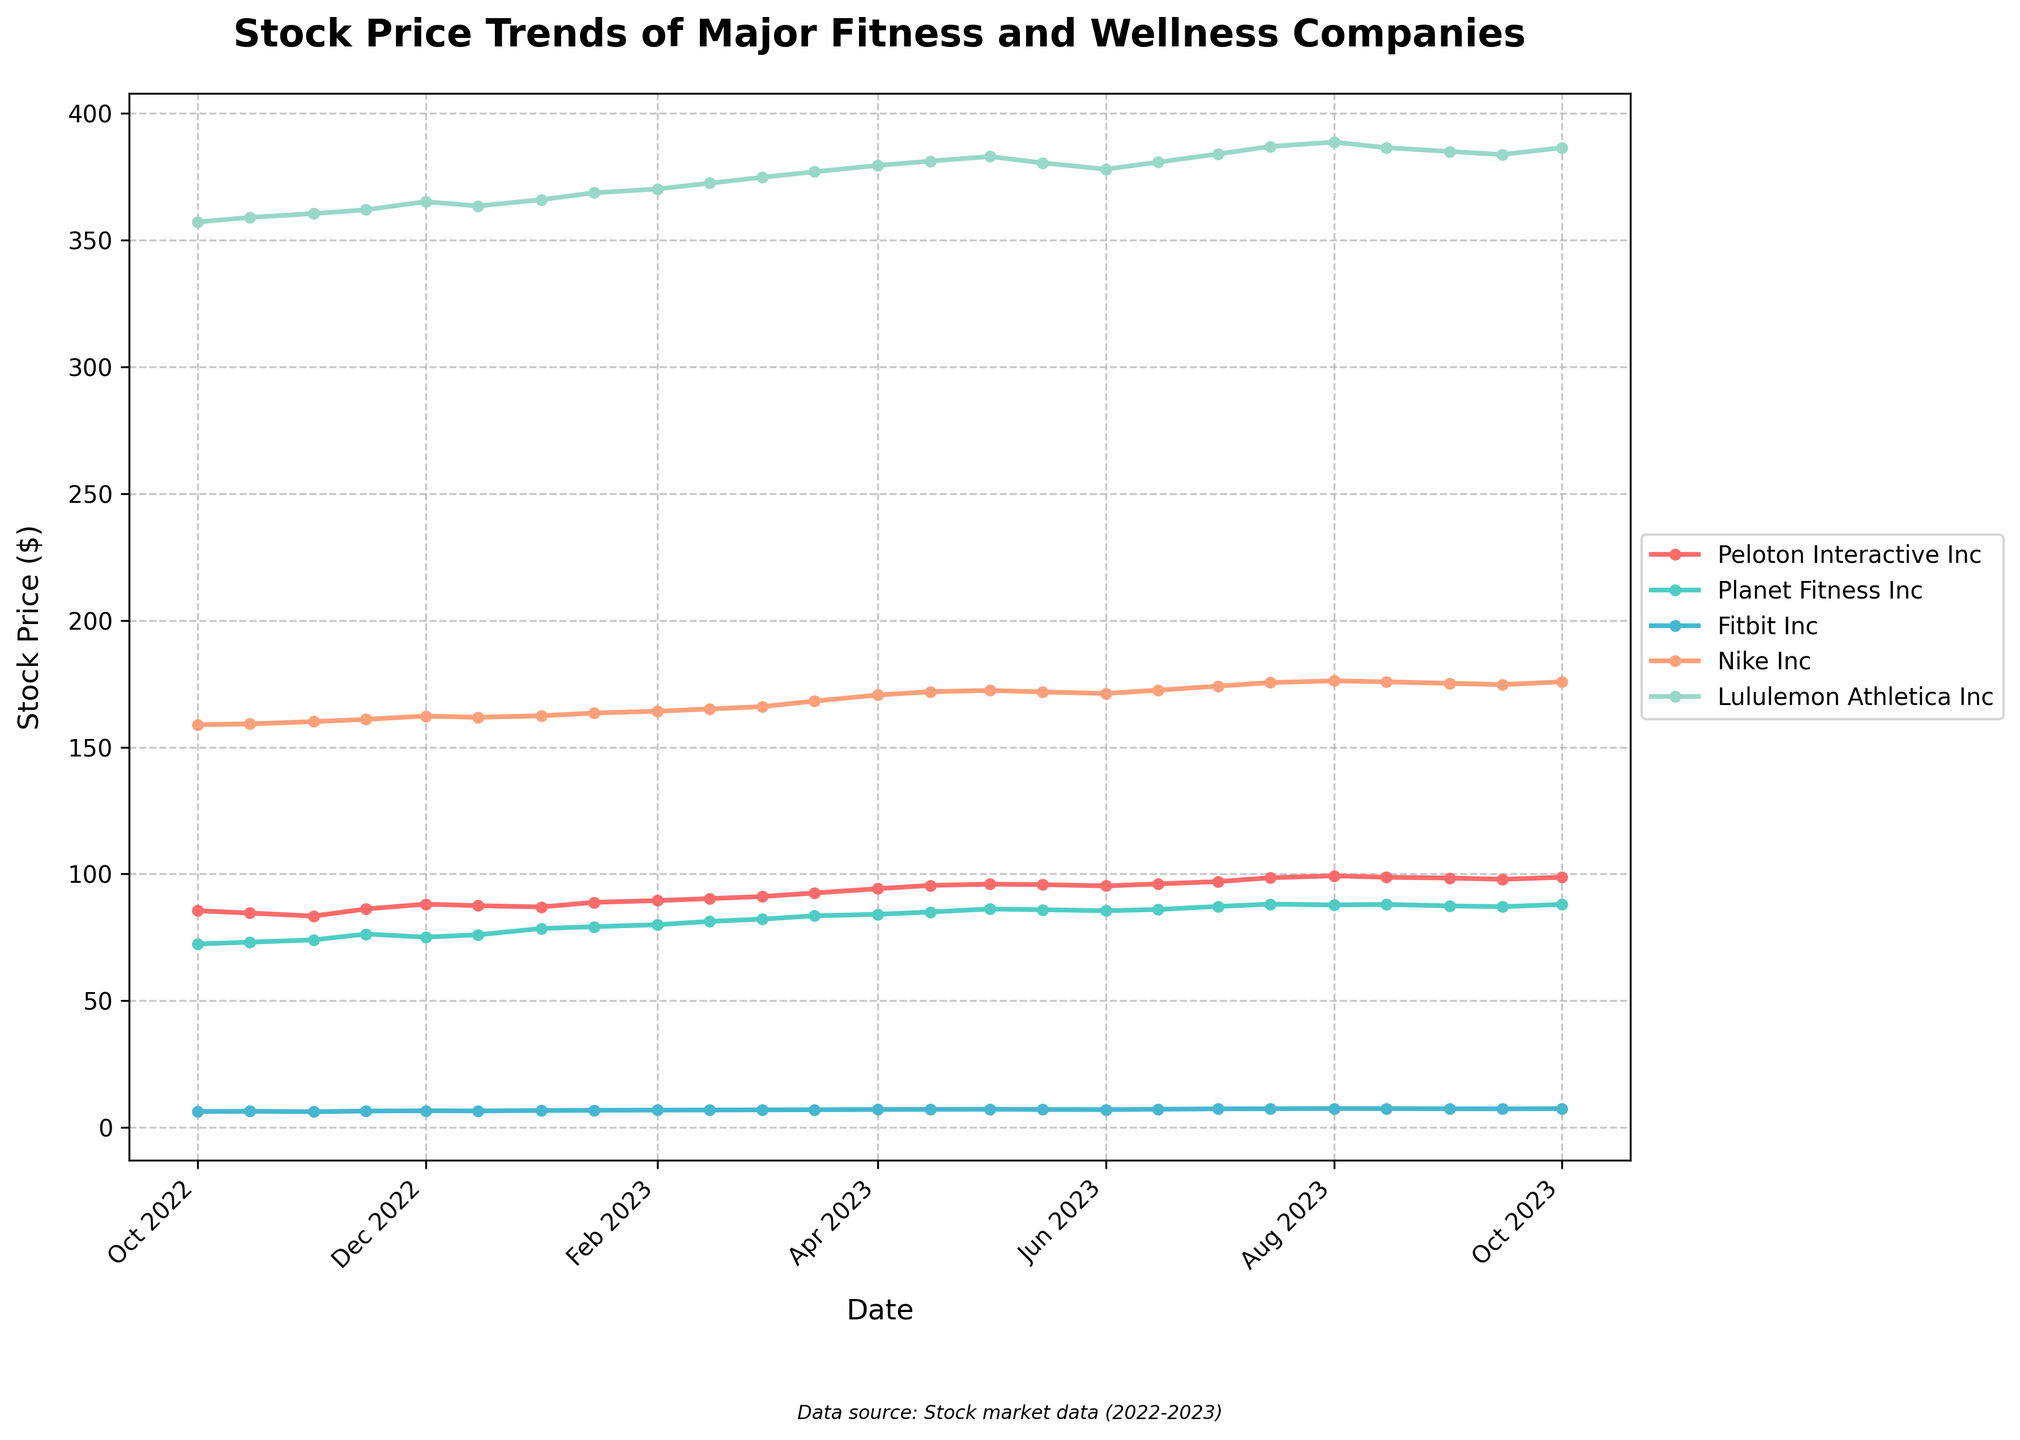What is the title of the plot? The title is positioned at the top of the plot and usually summarizes the main theme of the data being presented.
Answer: Stock Price Trends of Major Fitness and Wellness Companies Which company had the highest stock price on January 1, 2023? To determine this, find the stock prices for all companies on January 1, 2023, and identify the highest value.
Answer: Lululemon Athletica Inc How does Nike Inc's stock price on April 1, 2023, compare to its price on October 1, 2022? First, find Nike Inc's stock price on April 1, 2023, and October 1, 2022. Then, compare these two values.
Answer: It increased (from 158.90 to 170.60) How many data points are used for each company's stock price in the plot? The number of data points can be counted by looking at the timestamps available from October 2022 to October 2023 at regular intervals.
Answer: 25 What is the average stock price of Peloton Interactive Inc from October 2022 to October 2023? Add all the stock prices of Peloton Interactive Inc from October 2022 to October 2023 and divide by the number of data points.
Answer: 92.06 Which company has the most stable stock price trend over the year? A company with the most stable trend will show the smallest fluctuation in its stock prices when plotting the graph from October 2022 to October 2023.
Answer: Fitbit Inc On which date did Planet Fitness Inc have the highest stock price? Identify the maximum stock price for Planet Fitness Inc from the data and find the corresponding date.
Answer: August 1, 2023 How did Lululemon Athletica Inc's stock price change from August 1, 2023, to October 1, 2023? Check Lululemon's stock price on August 1, 2023, and compare it to the price on October 1, 2023, and note the difference.
Answer: Decreased by 2.2 (388.70 to 386.50) 